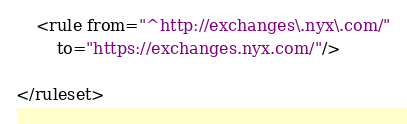<code> <loc_0><loc_0><loc_500><loc_500><_XML_>
	<rule from="^http://exchanges\.nyx\.com/"
		to="https://exchanges.nyx.com/"/>

</ruleset>
</code> 